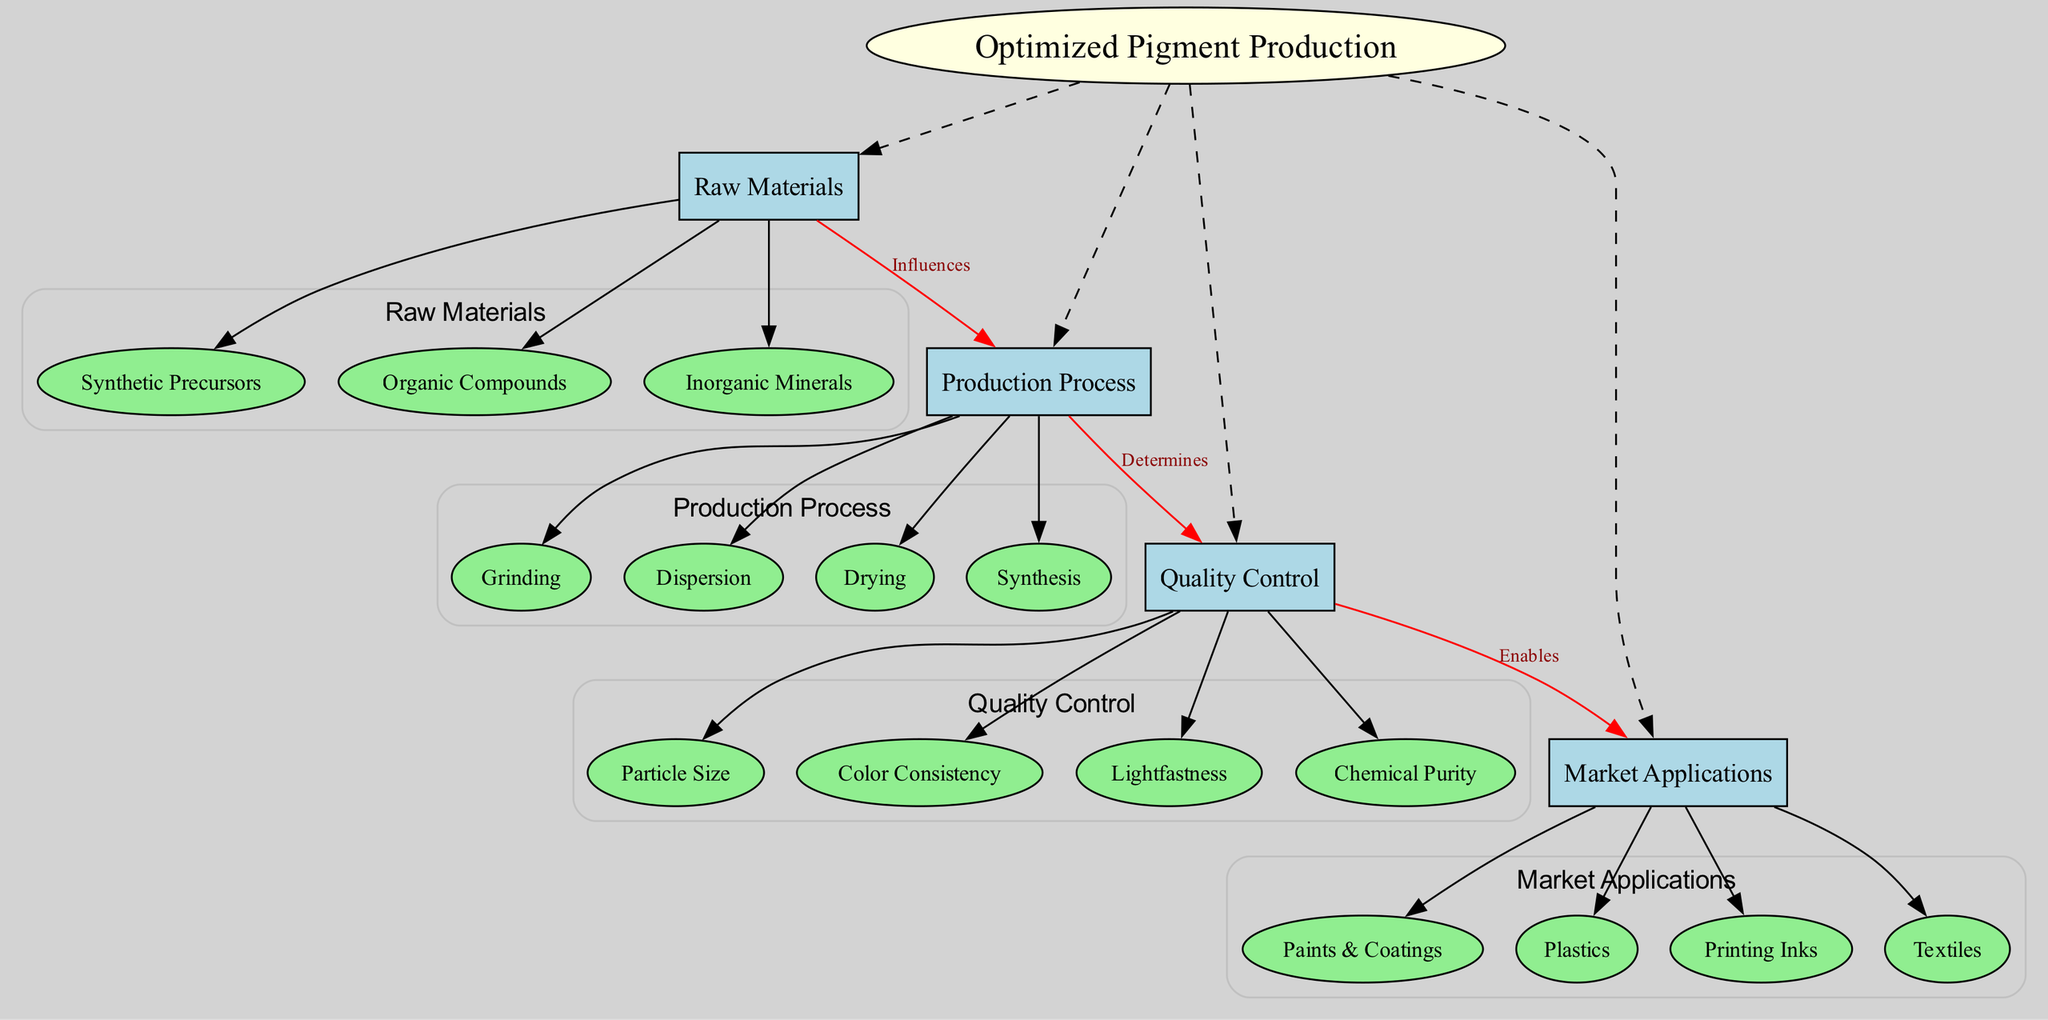What are the main nodes in this concept map? The main nodes are listed directly in the diagram as significant categories that relate to the central concept "Optimized Pigment Production." These include "Raw Materials," "Production Process," "Quality Control," and "Market Applications."
Answer: Raw Materials, Production Process, Quality Control, Market Applications How many sub-nodes are listed under "Production Process"? To find the answer, I refer to the sub-nodes under the main node "Production Process." There are four sub-nodes: "Synthesis," "Grinding," "Dispersion," and "Drying."
Answer: 4 Which node influences the "Production Process"? The connection labeled "Influences" from the node "Raw Materials" indicates that it affects the "Production Process." This shows a direct relationship where the quality or type of raw materials used will affect production techniques.
Answer: Raw Materials What does "Quality Control" determine? The connection labeled "Determines" between "Production Process" and "Quality Control" suggests that the aspects of the production process directly impact the results measured in quality control. It emphasizes that the production methods set the standards for quality checks.
Answer: Quality Control What are the quality factors mentioned under "Quality Control"? I can see that "Quality Control" has a list of four associated factors, specifically "Particle Size," "Color Consistency," "Lightfastness," and "Chemical Purity." These are essential criteria measured during the quality check.
Answer: Particle Size, Color Consistency, Lightfastness, Chemical Purity What enables "Market Applications"? The diagram shows that "Quality Control" enables "Market Applications," indicating that the quality checks and standards achieved in the production process allow the pigments to be effectively used in various market sectors.
Answer: Quality Control How many total connections are shown in the diagram? By counting the connections listed between the nodes, we can see there are three connections in total: one from "Raw Materials" to "Production Process," one from "Production Process" to "Quality Control," and one from "Quality Control" to "Market Applications."
Answer: 3 What are the market applications mentioned in the diagram? Under the main node "Market Applications," the sub-nodes include four areas listed: "Paints & Coatings," "Plastics," "Printing Inks," and "Textiles," showing diverse industries using the optimized pigments produced.
Answer: Paints & Coatings, Plastics, Printing Inks, Textiles Which sub-node describes a type of production technique? Focusing on the sub-nodes under "Production Process," we identify several techniques; "Synthesis" specifies a method to create the pigments, showcasing a key process in production.
Answer: Synthesis 